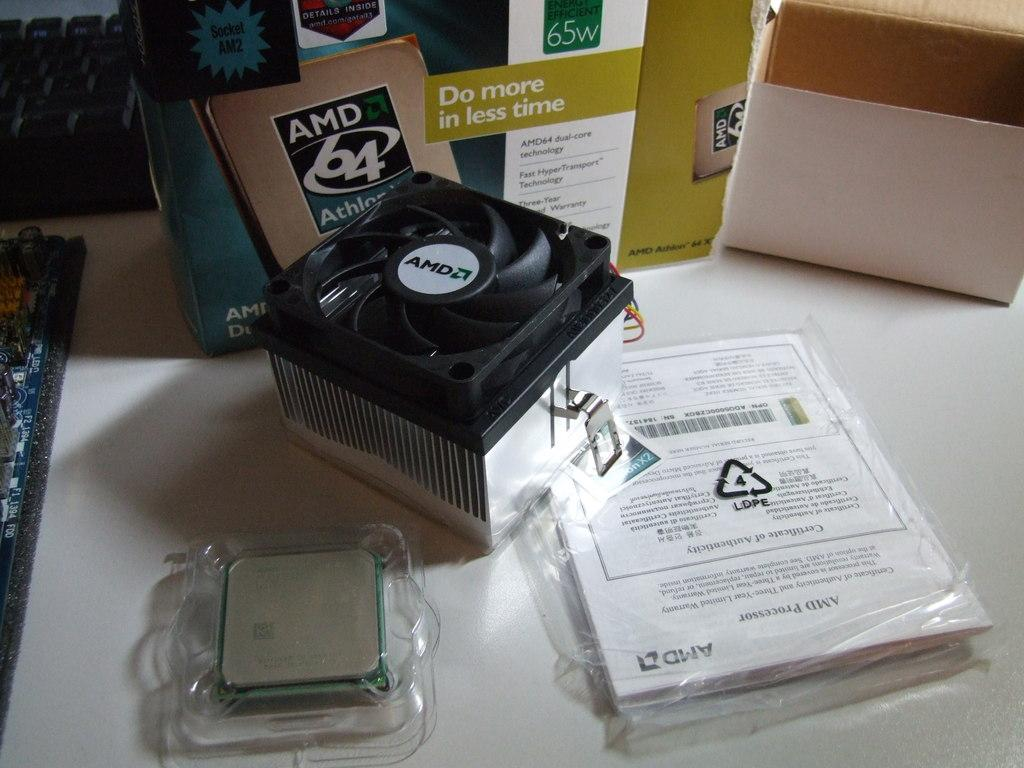<image>
Create a compact narrative representing the image presented. AMD Athlon chip is shown in front of its box on a white table. 